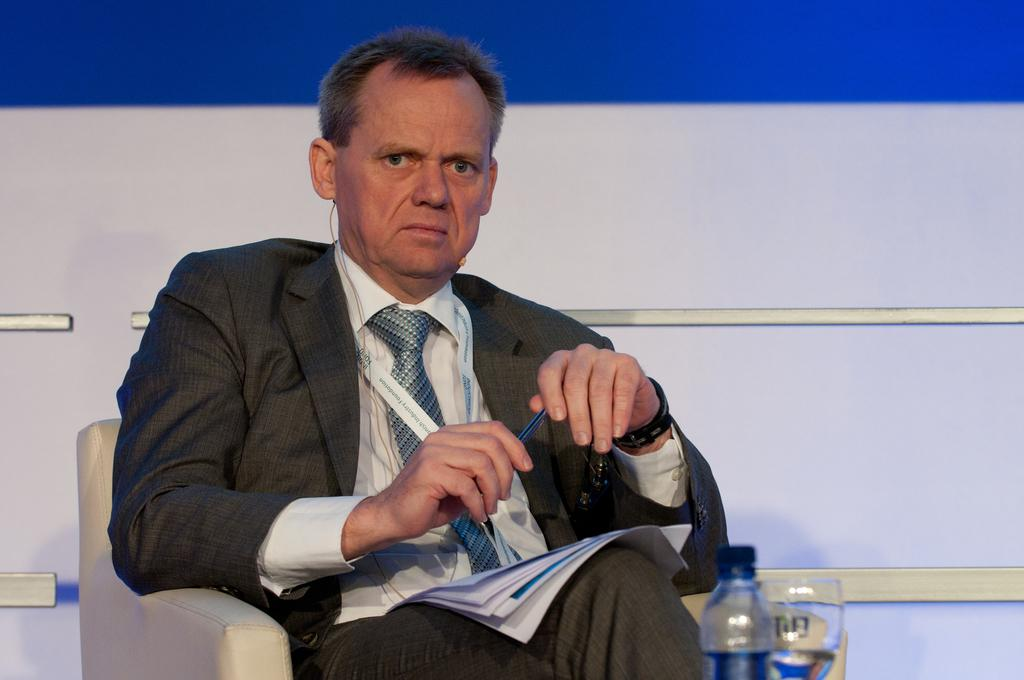Who is present in the image? There is a man in the image. What is the man doing in the image? The man is sitting on a sofa. What is the man holding in his hand? The man has a pen in his hand. What objects are placed before the man? There is a bottle and a glass placed before the man. What is the man doing with the book in the image? The book is placed on the man's laps. What type of turkey is being prepared in the image? There is no turkey present in the image; it features a man sitting on a sofa with various objects around him. How much salt is being used in the image? There is no salt present in the image. 